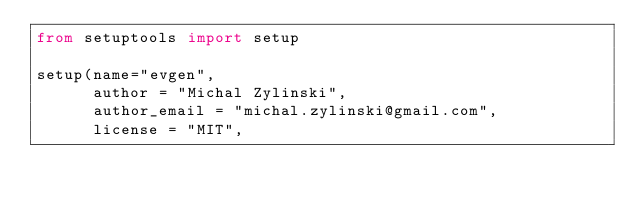<code> <loc_0><loc_0><loc_500><loc_500><_Python_>from setuptools import setup

setup(name="evgen", 
      author = "Michal Zylinski",
      author_email = "michal.zylinski@gmail.com",
      license = "MIT",</code> 